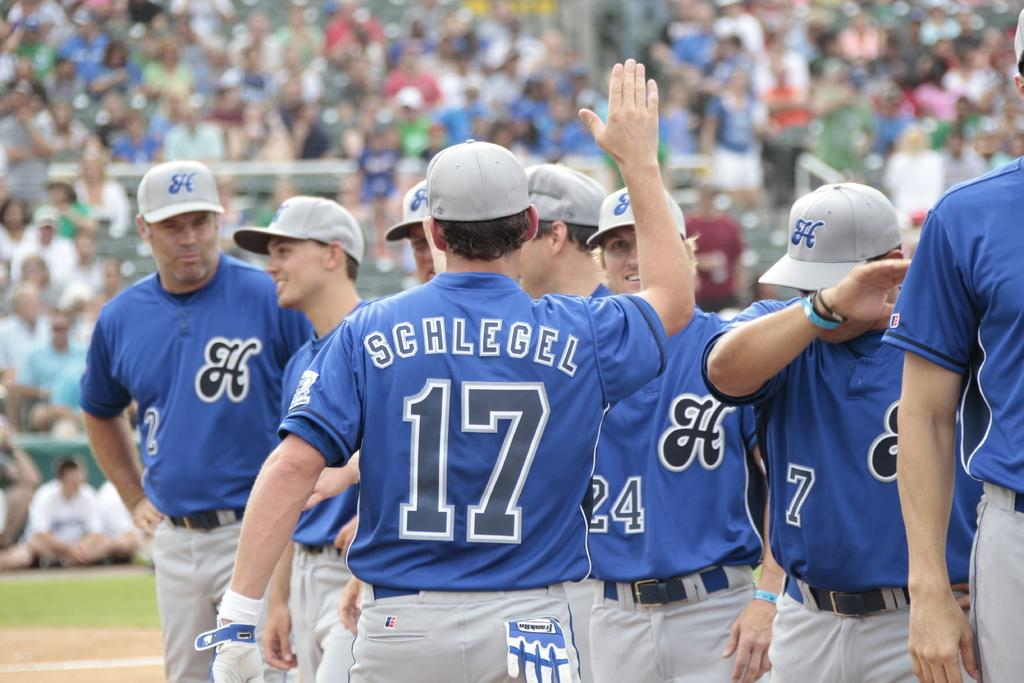<image>
Relay a brief, clear account of the picture shown. baseball players high fiving each other and one with the name schlegel 